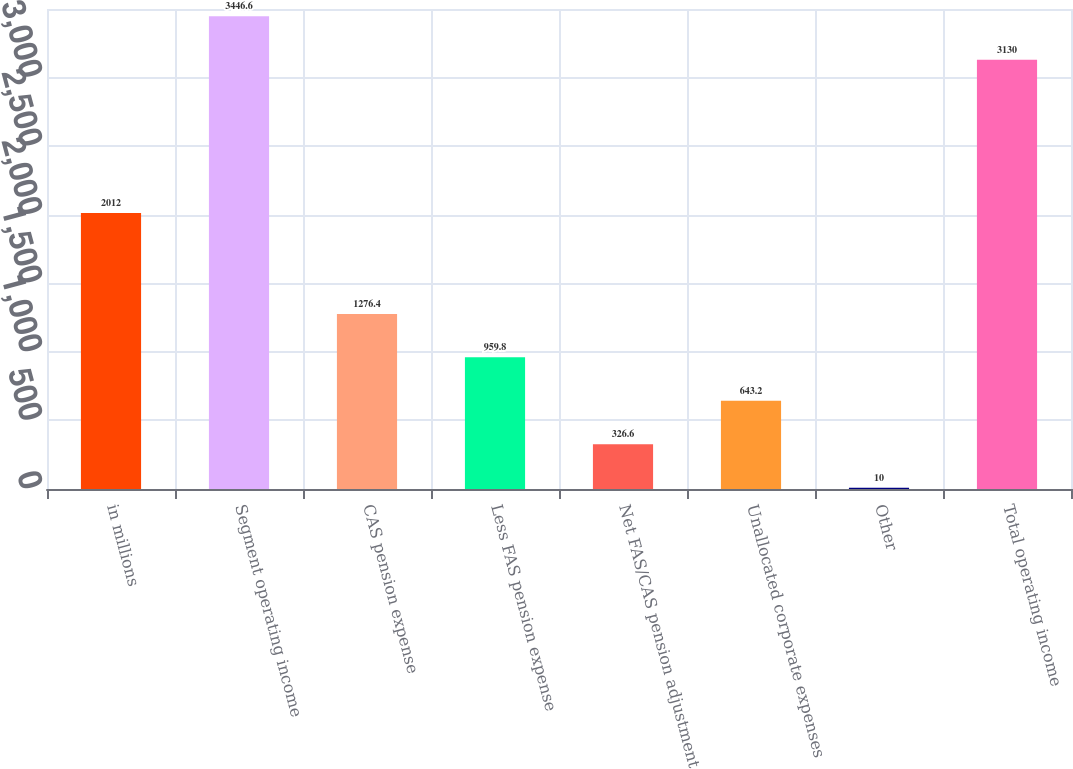Convert chart. <chart><loc_0><loc_0><loc_500><loc_500><bar_chart><fcel>in millions<fcel>Segment operating income<fcel>CAS pension expense<fcel>Less FAS pension expense<fcel>Net FAS/CAS pension adjustment<fcel>Unallocated corporate expenses<fcel>Other<fcel>Total operating income<nl><fcel>2012<fcel>3446.6<fcel>1276.4<fcel>959.8<fcel>326.6<fcel>643.2<fcel>10<fcel>3130<nl></chart> 